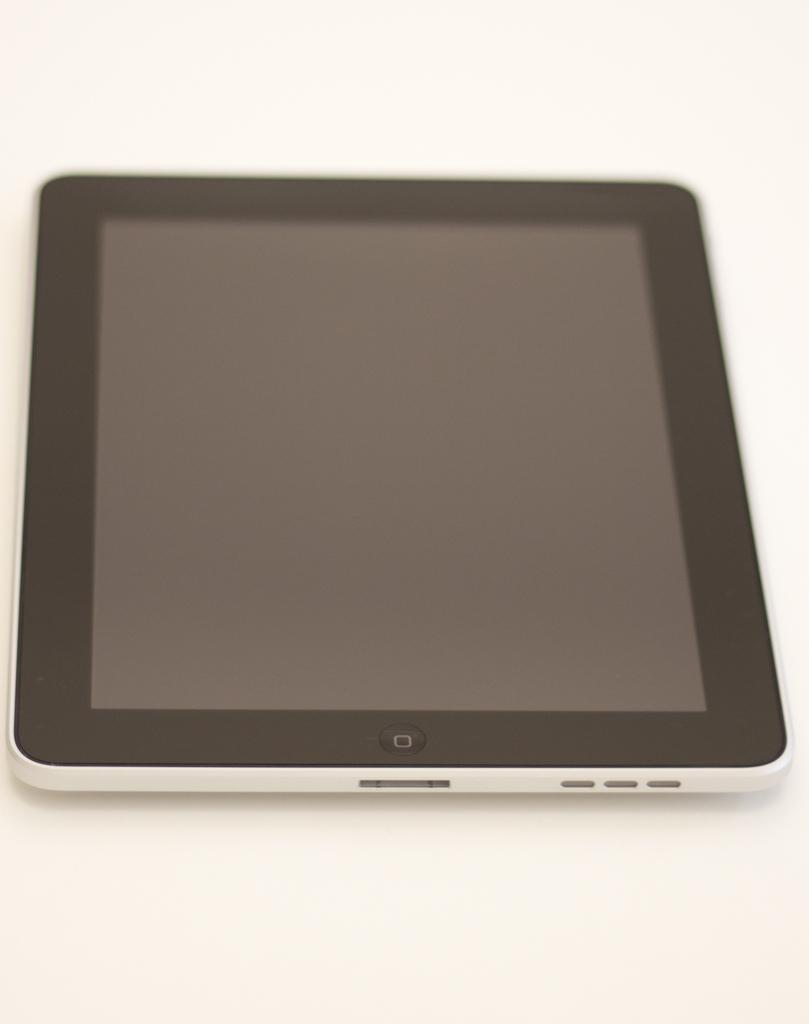What electronic device is visible in the image? There is a tablet device in the image. What is the tablet device placed on? The tablet device is on a white color platform. How many people are in the crowd surrounding the tablet device in the image? There is no crowd present in the image; it only shows a tablet device on a white color platform. 